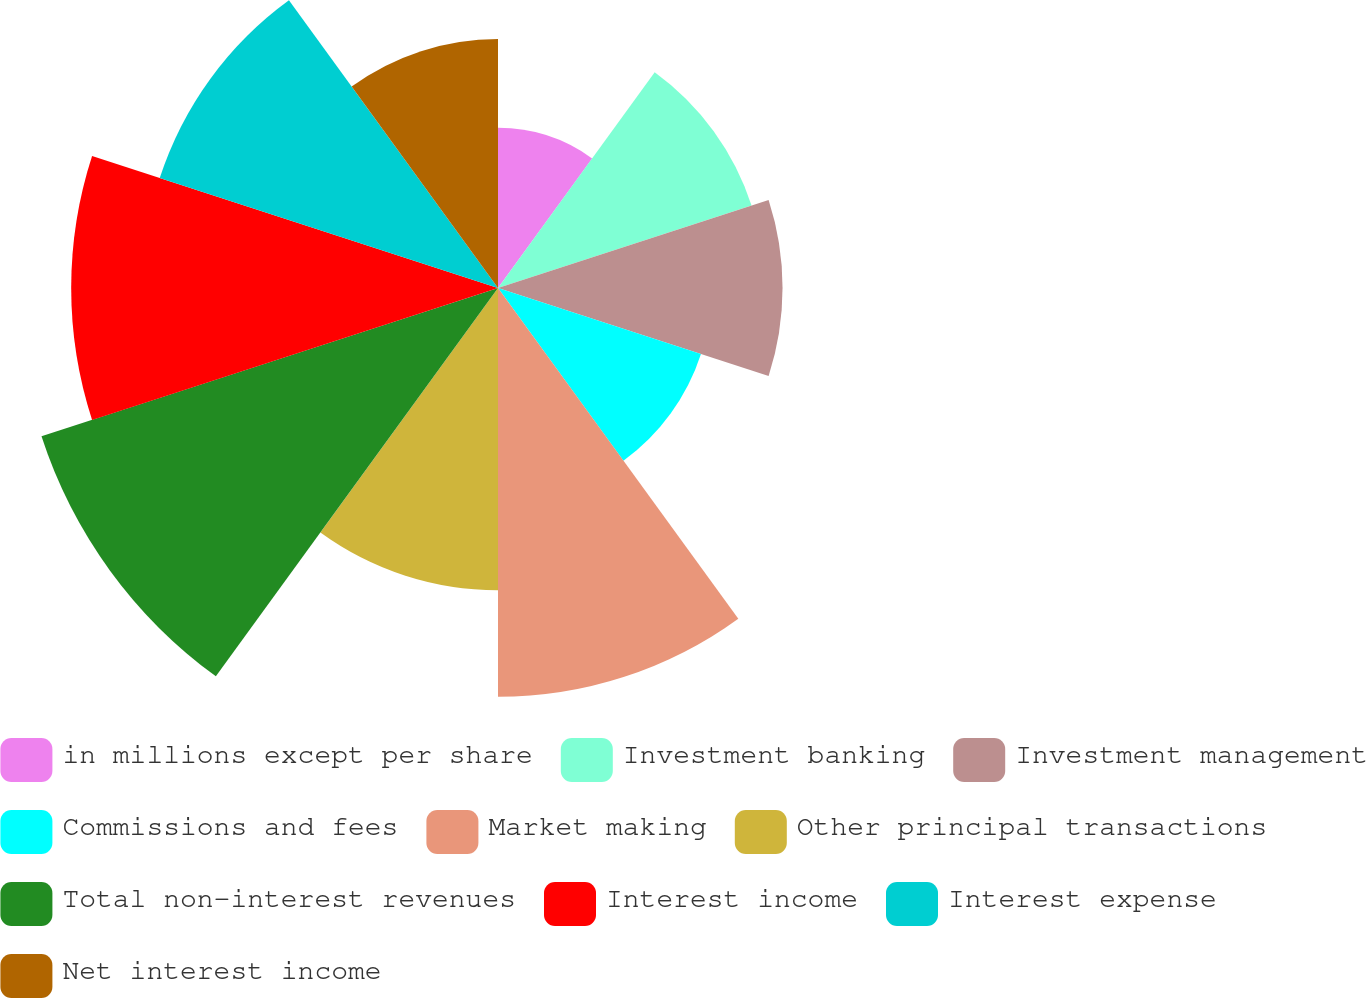<chart> <loc_0><loc_0><loc_500><loc_500><pie_chart><fcel>in millions except per share<fcel>Investment banking<fcel>Investment management<fcel>Commissions and fees<fcel>Market making<fcel>Other principal transactions<fcel>Total non-interest revenues<fcel>Interest income<fcel>Interest expense<fcel>Net interest income<nl><fcel>5.09%<fcel>8.47%<fcel>9.04%<fcel>6.78%<fcel>12.99%<fcel>9.6%<fcel>15.25%<fcel>13.56%<fcel>11.3%<fcel>7.91%<nl></chart> 